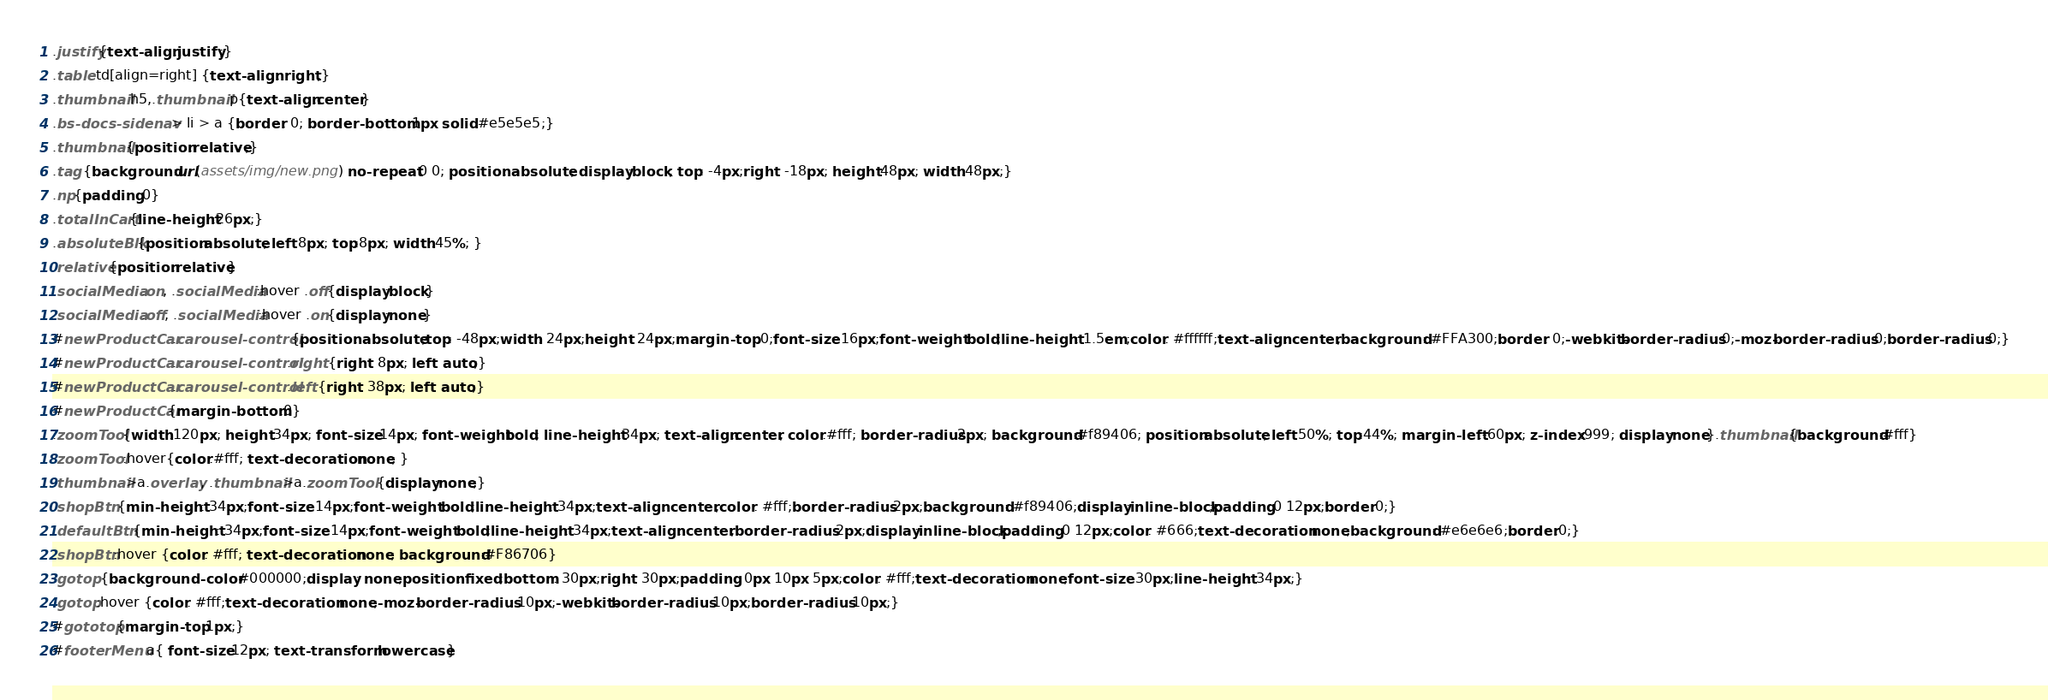Convert code to text. <code><loc_0><loc_0><loc_500><loc_500><_CSS_>.justify{text-align:justify;}
.table td[align=right] {text-align: right;}
.thumbnail h5,.thumbnail p{text-align:center}
.bs-docs-sidenav > li > a {border: 0; border-bottom:1px solid #e5e5e5;}
.thumbnail{position:relative;}
.tag {background:url(assets/img/new.png) no-repeat 0 0; position: absolute; display:block; top: -4px;right: -18px; height:48px; width:48px;}
.np{padding:0}
.totalInCart{line-height:26px;}
.absoluteBlk{position:absolute; left:8px; top:8px; width:45%; }
.relative{position:relative}
.socialMedia .on, .socialMedia:hover .off{display:block}
.socialMedia .off, .socialMedia:hover .on{display:none}
#newProductCar .carousel-control {position: absolute;top: -48px;width: 24px;height: 24px;margin-top: 0;font-size: 16px;font-weight: bold;line-height: 1.5em;color: #ffffff;text-align: center;background: #FFA300;border: 0;-webkit-border-radius: 0;-moz-border-radius: 0;border-radius: 0;}
#newProductCar .carousel-control.right {right: 8px; left: auto;}
#newProductCar .carousel-control.left {right: 38px; left: auto;}
#newProductCar{margin-bottom:0}
.zoomTool{width:120px; height:34px; font-size:14px; font-weight:bold; line-height:34px; text-align:center; color:#fff; border-radius:2px; background:#f89406; position:absolute; left:50%; top:44%; margin-left:-60px; z-index:999; display:none}.thumbnail{background:#fff}
.zoomTool:hover{color:#fff; text-decoration:none; }
.thumbnail>a.overlay, .thumbnail>a.zoomTool {display:none;}
.shopBtn {min-height: 34px;font-size: 14px;font-weight: bold;line-height: 34px;text-align: center;color: #fff;border-radius: 2px;background: #f89406;display:inline-block;padding:0 12px;border:0;}
.defaultBtn {min-height: 34px;font-size: 14px;font-weight: bold;line-height: 34px;text-align: center;border-radius: 2px;display:inline-block;padding:0 12px;color: #666;text-decoration: none;background: #e6e6e6;border:0;}
.shopBtn:hover {color: #fff; text-decoration:none; background:#F86706}
.gotop {background-color: #000000;display: none;position: fixed;bottom: 30px;right: 30px;padding: 0px 10px 5px;color: #fff;text-decoration: none;font-size: 30px;line-height: 34px;}
.gotop:hover {color: #fff;text-decoration: none;-moz-border-radius: 10px;-webkit-border-radius: 10px;border-radius: 10px;}
#gototop{margin-top:1px;}
#footerMenu a{ font-size:12px; text-transform:lowercase}</code> 